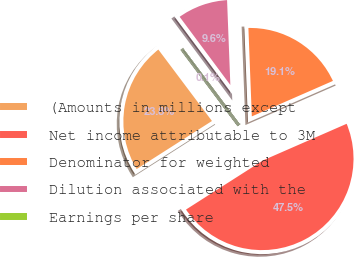Convert chart to OTSL. <chart><loc_0><loc_0><loc_500><loc_500><pie_chart><fcel>(Amounts in millions except<fcel>Net income attributable to 3M<fcel>Denominator for weighted<fcel>Dilution associated with the<fcel>Earnings per share<nl><fcel>23.8%<fcel>47.52%<fcel>19.05%<fcel>9.56%<fcel>0.07%<nl></chart> 